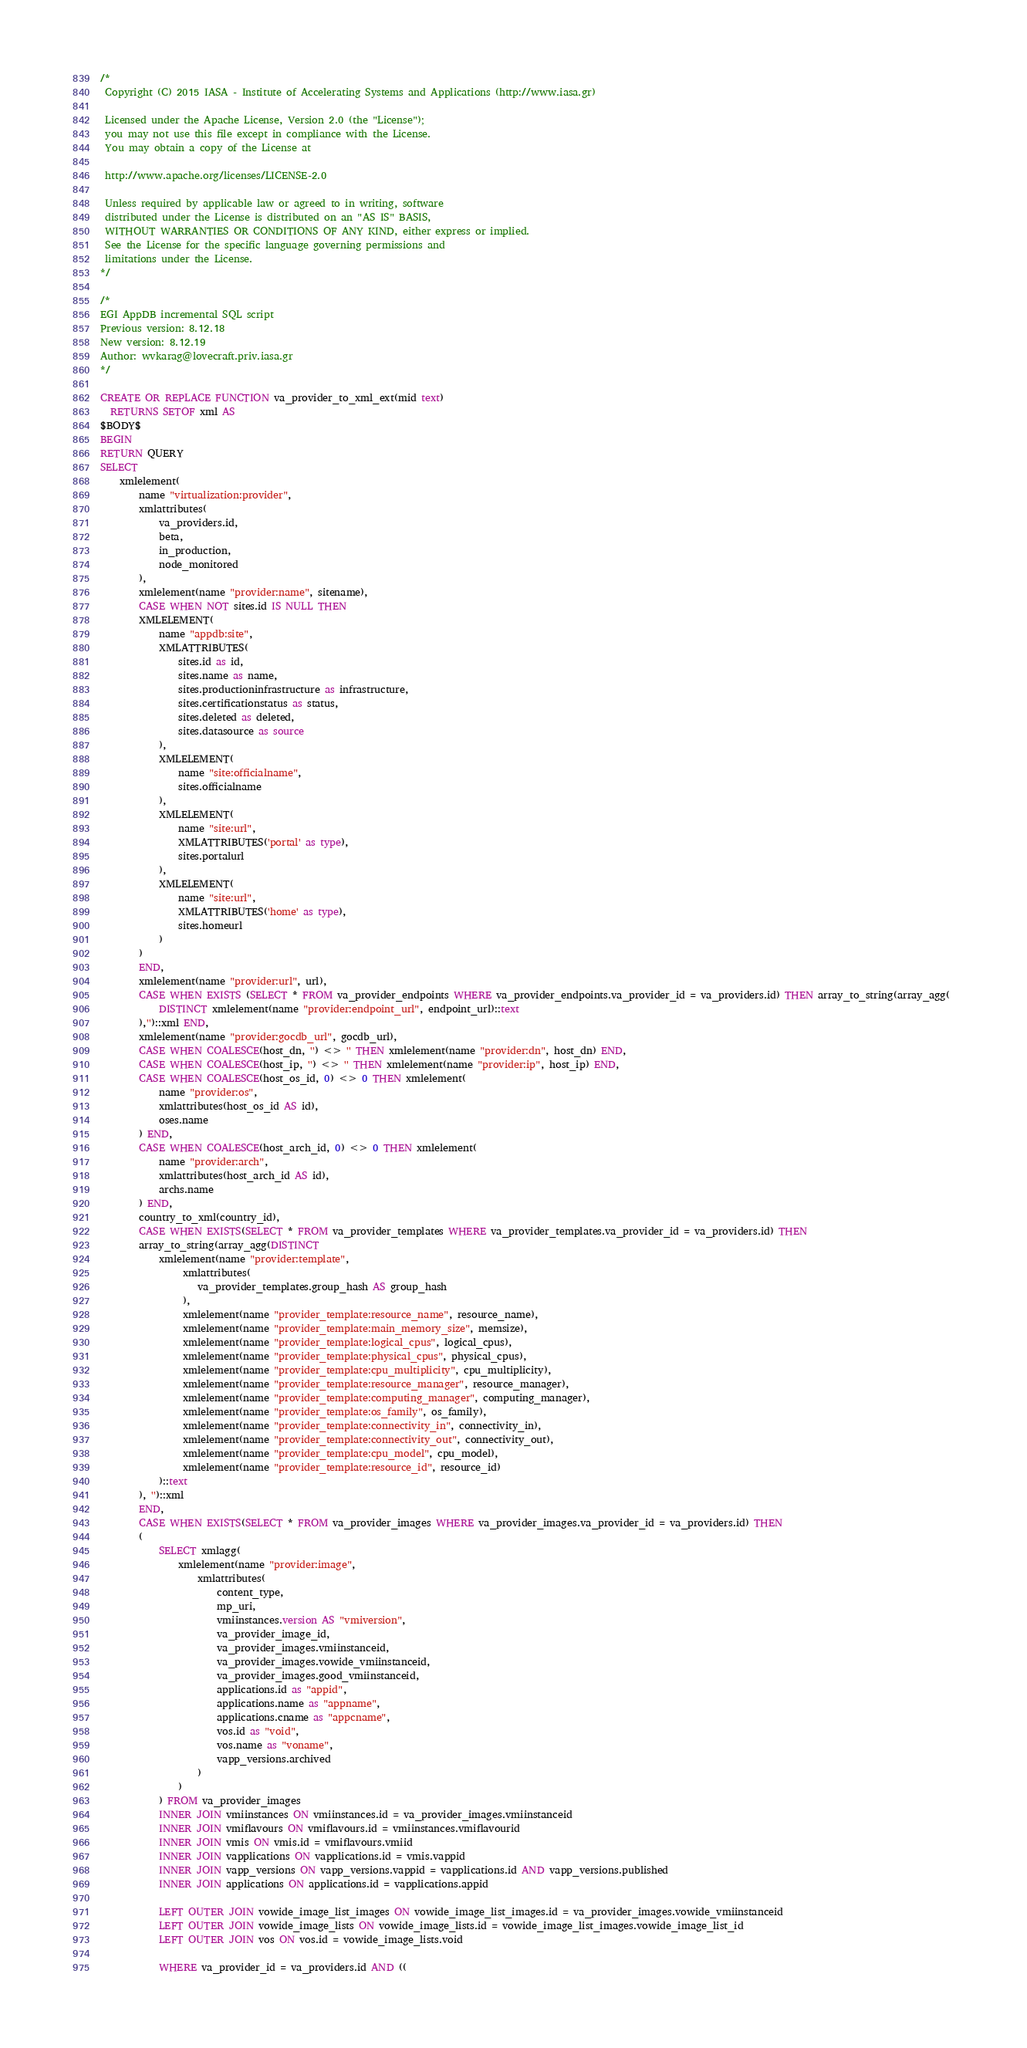Convert code to text. <code><loc_0><loc_0><loc_500><loc_500><_SQL_>/*
 Copyright (C) 2015 IASA - Institute of Accelerating Systems and Applications (http://www.iasa.gr)

 Licensed under the Apache License, Version 2.0 (the "License");
 you may not use this file except in compliance with the License.
 You may obtain a copy of the License at
 
 http://www.apache.org/licenses/LICENSE-2.0

 Unless required by applicable law or agreed to in writing, software
 distributed under the License is distributed on an "AS IS" BASIS,
 WITHOUT WARRANTIES OR CONDITIONS OF ANY KIND, either express or implied.
 See the License for the specific language governing permissions and 
 limitations under the License.
*/

/* 
EGI AppDB incremental SQL script
Previous version: 8.12.18
New version: 8.12.19
Author: wvkarag@lovecraft.priv.iasa.gr
*/

CREATE OR REPLACE FUNCTION va_provider_to_xml_ext(mid text)
  RETURNS SETOF xml AS
$BODY$
BEGIN
RETURN QUERY
SELECT 
	xmlelement(
		name "virtualization:provider", 
		xmlattributes(
			va_providers.id,
			beta,
			in_production,
			node_monitored
		),
		xmlelement(name "provider:name", sitename),
		CASE WHEN NOT sites.id IS NULL THEN
		XMLELEMENT(
			name "appdb:site", 
			XMLATTRIBUTES(
				sites.id as id,
				sites.name as name,
				sites.productioninfrastructure as infrastructure, 
				sites.certificationstatus as status,
				sites.deleted as deleted,
				sites.datasource as source
			),
			XMLELEMENT(
				name "site:officialname", 
				sites.officialname
			), 
			XMLELEMENT(
				name "site:url", 
				XMLATTRIBUTES('portal' as type),
				sites.portalurl
			), 
			XMLELEMENT(
				name "site:url", 
				XMLATTRIBUTES('home' as type), 
				sites.homeurl
			)
		)
		END,
		xmlelement(name "provider:url", url),
		CASE WHEN EXISTS (SELECT * FROM va_provider_endpoints WHERE va_provider_endpoints.va_provider_id = va_providers.id) THEN array_to_string(array_agg( 
			DISTINCT xmlelement(name "provider:endpoint_url", endpoint_url)::text
		),'')::xml END,
		xmlelement(name "provider:gocdb_url", gocdb_url),
		CASE WHEN COALESCE(host_dn, '') <> '' THEN xmlelement(name "provider:dn", host_dn) END,
		CASE WHEN COALESCE(host_ip, '') <> '' THEN xmlelement(name "provider:ip", host_ip) END,
		CASE WHEN COALESCE(host_os_id, 0) <> 0 THEN xmlelement(
			name "provider:os", 
			xmlattributes(host_os_id AS id),
			oses.name
		) END,
		CASE WHEN COALESCE(host_arch_id, 0) <> 0 THEN xmlelement(
			name "provider:arch", 
			xmlattributes(host_arch_id AS id),
			archs.name
		) END,
		country_to_xml(country_id),
		CASE WHEN EXISTS(SELECT * FROM va_provider_templates WHERE va_provider_templates.va_provider_id = va_providers.id) THEN
		array_to_string(array_agg(DISTINCT
			xmlelement(name "provider:template",
				 xmlattributes(
					va_provider_templates.group_hash AS group_hash
				 ),
				 xmlelement(name "provider_template:resource_name", resource_name),
				 xmlelement(name "provider_template:main_memory_size", memsize),
				 xmlelement(name "provider_template:logical_cpus", logical_cpus),
				 xmlelement(name "provider_template:physical_cpus", physical_cpus),
				 xmlelement(name "provider_template:cpu_multiplicity", cpu_multiplicity),
				 xmlelement(name "provider_template:resource_manager", resource_manager),
				 xmlelement(name "provider_template:computing_manager", computing_manager),
				 xmlelement(name "provider_template:os_family", os_family),
				 xmlelement(name "provider_template:connectivity_in", connectivity_in),
				 xmlelement(name "provider_template:connectivity_out", connectivity_out),
				 xmlelement(name "provider_template:cpu_model", cpu_model),
				 xmlelement(name "provider_template:resource_id", resource_id)
			)::text
		), '')::xml
		END,
		CASE WHEN EXISTS(SELECT * FROM va_provider_images WHERE va_provider_images.va_provider_id = va_providers.id) THEN
		(
			SELECT xmlagg(
				xmlelement(name "provider:image",
					xmlattributes(
						content_type,
						mp_uri,
						vmiinstances.version AS "vmiversion",
						va_provider_image_id,
						va_provider_images.vmiinstanceid,
						va_provider_images.vowide_vmiinstanceid,	
						va_provider_images.good_vmiinstanceid,
						applications.id as "appid", 
						applications.name as "appname", 
						applications.cname as "appcname", 
						vos.id as "void", 
						vos.name as "voname",
						vapp_versions.archived
					)
				)
			) FROM va_provider_images 
			INNER JOIN vmiinstances ON vmiinstances.id = va_provider_images.vmiinstanceid
			INNER JOIN vmiflavours ON vmiflavours.id = vmiinstances.vmiflavourid
			INNER JOIN vmis ON vmis.id = vmiflavours.vmiid
			INNER JOIN vapplications ON vapplications.id = vmis.vappid
			INNER JOIN vapp_versions ON vapp_versions.vappid = vapplications.id AND vapp_versions.published
			INNER JOIN applications ON applications.id = vapplications.appid

			LEFT OUTER JOIN vowide_image_list_images ON vowide_image_list_images.id = va_provider_images.vowide_vmiinstanceid
			LEFT OUTER JOIN vowide_image_lists ON vowide_image_lists.id = vowide_image_list_images.vowide_image_list_id
			LEFT OUTER JOIN vos ON vos.id = vowide_image_lists.void
			
			WHERE va_provider_id = va_providers.id AND ((</code> 